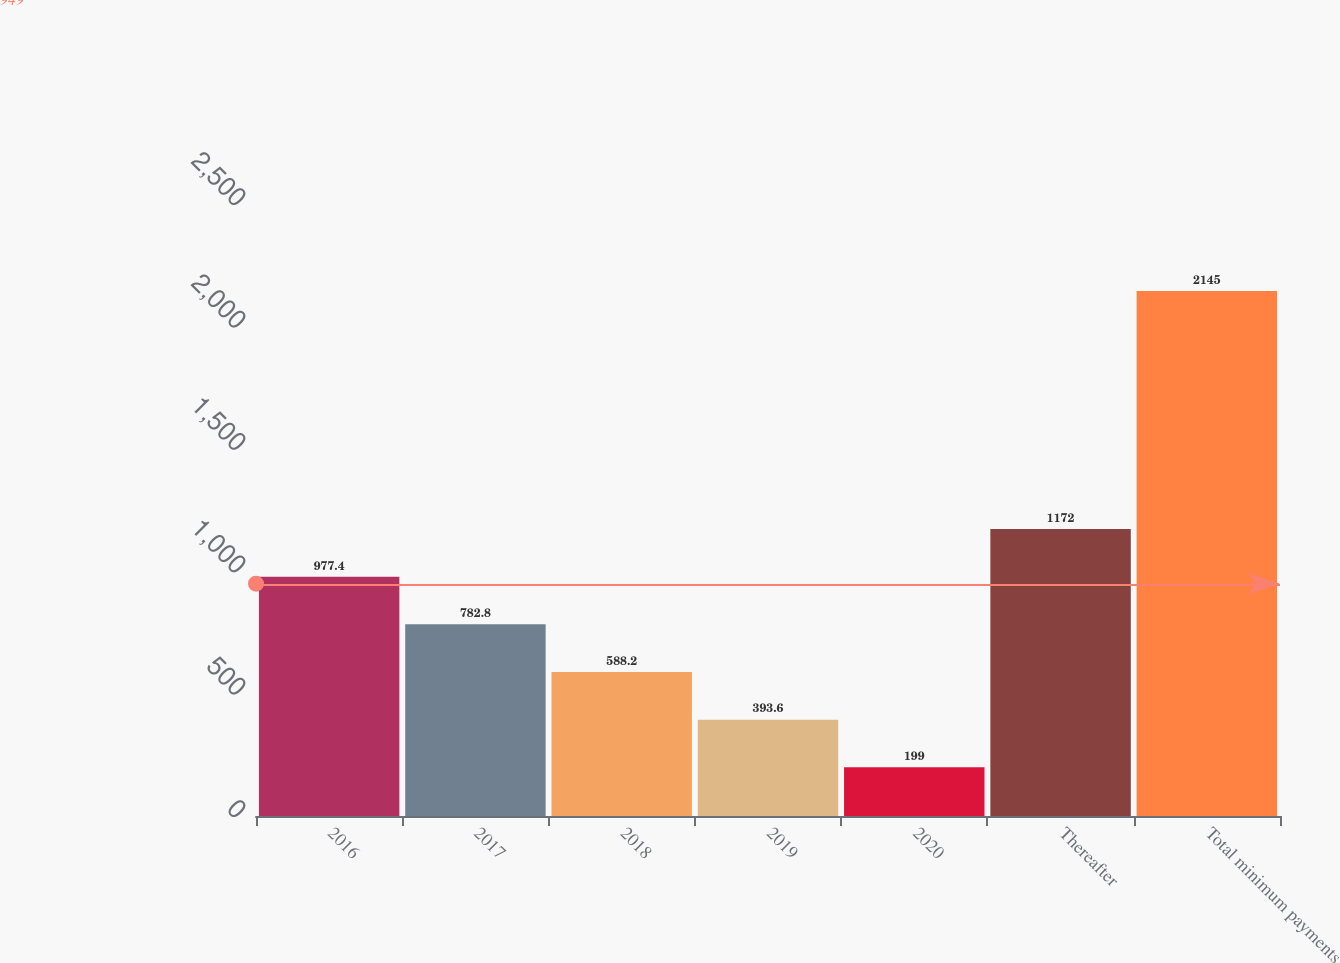Convert chart. <chart><loc_0><loc_0><loc_500><loc_500><bar_chart><fcel>2016<fcel>2017<fcel>2018<fcel>2019<fcel>2020<fcel>Thereafter<fcel>Total minimum payments<nl><fcel>977.4<fcel>782.8<fcel>588.2<fcel>393.6<fcel>199<fcel>1172<fcel>2145<nl></chart> 